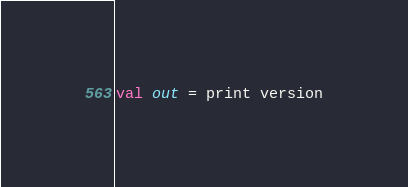<code> <loc_0><loc_0><loc_500><loc_500><_SML_>val out = print version
</code> 